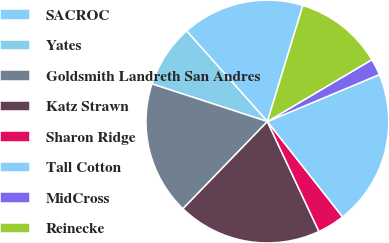Convert chart to OTSL. <chart><loc_0><loc_0><loc_500><loc_500><pie_chart><fcel>SACROC<fcel>Yates<fcel>Goldsmith Landreth San Andres<fcel>Katz Strawn<fcel>Sharon Ridge<fcel>Tall Cotton<fcel>MidCross<fcel>Reinecke<nl><fcel>16.31%<fcel>8.4%<fcel>17.77%<fcel>19.23%<fcel>3.65%<fcel>20.69%<fcel>2.19%<fcel>11.77%<nl></chart> 